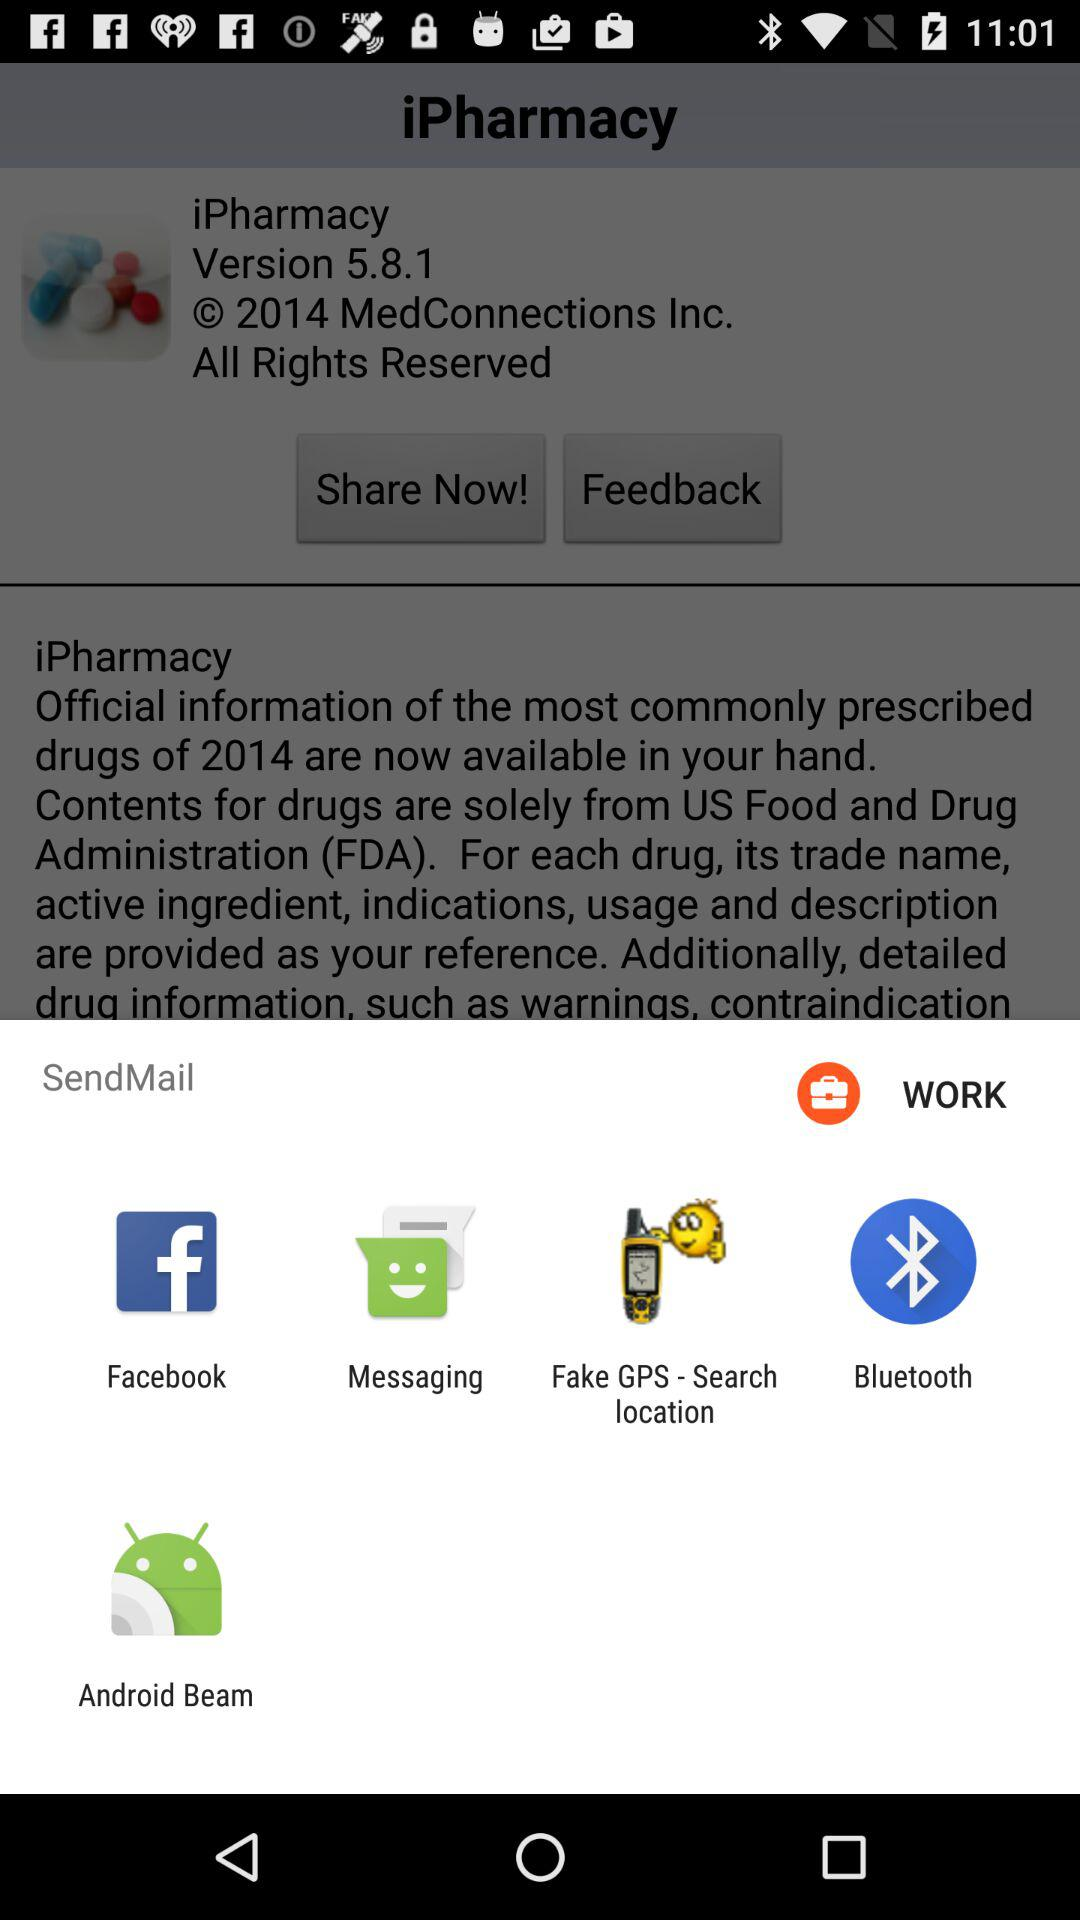What is the application name? The application name is "iPharmacy". 